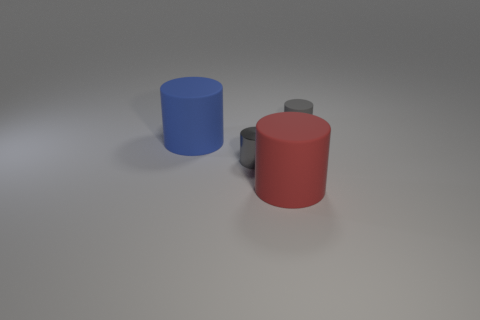Add 4 red things. How many objects exist? 8 Add 3 big blue objects. How many big blue objects exist? 4 Subtract 1 blue cylinders. How many objects are left? 3 Subtract all purple balls. Subtract all small cylinders. How many objects are left? 2 Add 2 small gray shiny cylinders. How many small gray shiny cylinders are left? 3 